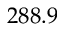Convert formula to latex. <formula><loc_0><loc_0><loc_500><loc_500>2 8 8 . 9</formula> 